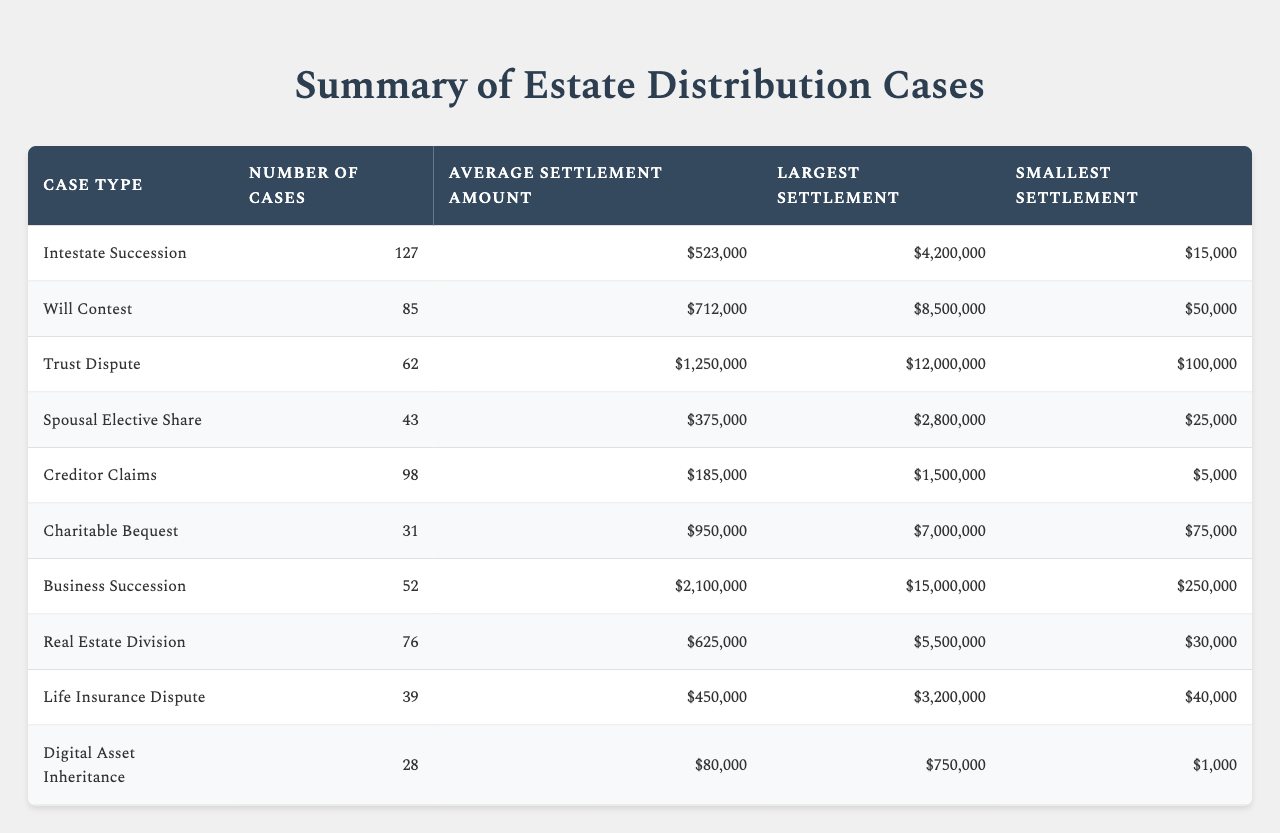What is the case type with the largest average settlement amount? The table shows the average settlement amounts for each case type. The "Business Succession" case type has the largest average settlement amount of $2,100,000, compared to others like "Trust Dispute" with $1,250,000.
Answer: Business Succession How many cases were involved in Will Contests? The table lists the number of cases for each type, and the "Will Contest" category shows 85 cases.
Answer: 85 What is the smallest settlement amount recorded in Trust Dispute cases? Referring to the "Trust Dispute" row in the table, the smallest settlement is $100,000.
Answer: $100,000 Which case type had the lowest average settlement amount? By comparing the average settlement amounts, "Creditor Claims" has the lowest average at $185,000 among all case types.
Answer: Creditor Claims What is the total number of cases across all case types? To find the total number of cases, we add all the "Number of Cases" values: 127 + 85 + 62 + 43 + 98 + 31 + 52 + 76 + 39 + 28 = 610.
Answer: 610 Does the case type "Digital Asset Inheritance" have an average settlement greater than $200,000? The average settlement for "Digital Asset Inheritance" is $80,000, which is less than $200,000. Therefore, the answer is no.
Answer: No What is the difference between the largest and smallest settlements in all cases? The largest settlement across all cases is $15,000,000 (from "Business Succession") and the smallest is $1,000 (from "Digital Asset Inheritance"). Calculating the difference: $15,000,000 - $1,000 = $14,999,000.
Answer: $14,999,000 Which case type has the highest largest settlement amount and what is that amount? The "Business Succession" case type has the highest largest settlement amount of $15,000,000 documented in the table.
Answer: $15,000,000 What is the average settlement amount for Will Contests compared to Spousal Elective Share? The average settlement amount for "Will Contest" is $712,000 and for "Spousal Elective Share" it is $375,000. Comparing the two, Will Contest is higher by $337,000.
Answer: $337,000 Is the average settlement for Charitable Bequest more than $900,000? The average settlement for "Charitable Bequest" is $950,000, which is more than $900,000. Therefore, the answer is yes.
Answer: Yes 